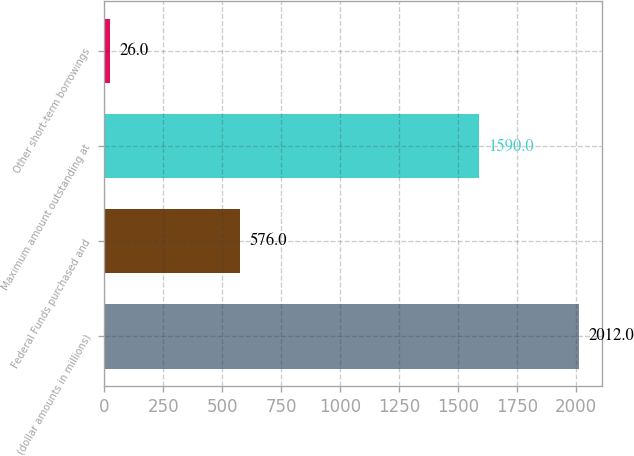Convert chart to OTSL. <chart><loc_0><loc_0><loc_500><loc_500><bar_chart><fcel>(dollar amounts in millions)<fcel>Federal Funds purchased and<fcel>Maximum amount outstanding at<fcel>Other short-term borrowings<nl><fcel>2012<fcel>576<fcel>1590<fcel>26<nl></chart> 